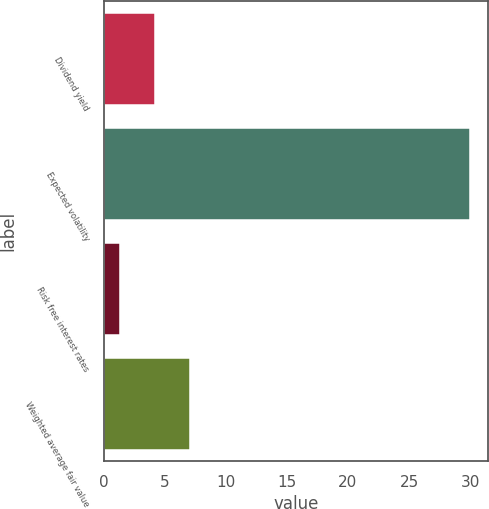Convert chart to OTSL. <chart><loc_0><loc_0><loc_500><loc_500><bar_chart><fcel>Dividend yield<fcel>Expected volatility<fcel>Risk free interest rates<fcel>Weighted average fair value<nl><fcel>4.17<fcel>30<fcel>1.3<fcel>7.04<nl></chart> 